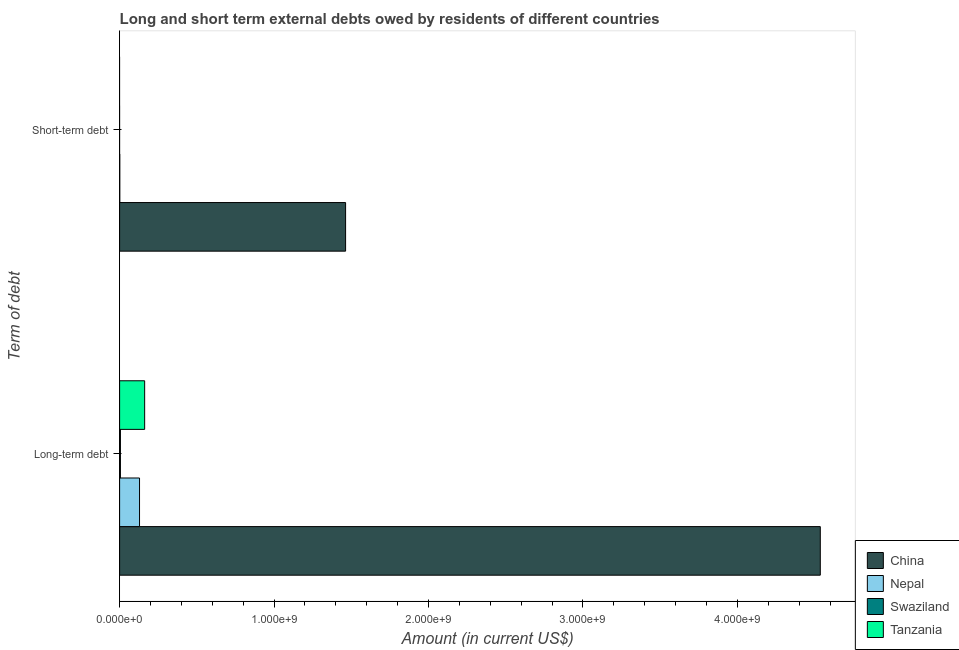How many bars are there on the 2nd tick from the top?
Your answer should be compact. 4. What is the label of the 2nd group of bars from the top?
Offer a very short reply. Long-term debt. Across all countries, what is the maximum long-term debts owed by residents?
Give a very brief answer. 4.54e+09. Across all countries, what is the minimum short-term debts owed by residents?
Provide a succinct answer. 0. What is the total short-term debts owed by residents in the graph?
Make the answer very short. 1.46e+09. What is the difference between the long-term debts owed by residents in Nepal and that in China?
Your response must be concise. -4.41e+09. What is the difference between the short-term debts owed by residents in Swaziland and the long-term debts owed by residents in Tanzania?
Your response must be concise. -1.62e+08. What is the average long-term debts owed by residents per country?
Provide a short and direct response. 1.21e+09. What is the difference between the short-term debts owed by residents and long-term debts owed by residents in Nepal?
Provide a succinct answer. -1.28e+08. What is the ratio of the long-term debts owed by residents in Swaziland to that in Tanzania?
Your answer should be compact. 0.03. Is the long-term debts owed by residents in Nepal less than that in Swaziland?
Ensure brevity in your answer.  No. How many countries are there in the graph?
Your answer should be compact. 4. Are the values on the major ticks of X-axis written in scientific E-notation?
Give a very brief answer. Yes. Where does the legend appear in the graph?
Keep it short and to the point. Bottom right. How are the legend labels stacked?
Make the answer very short. Vertical. What is the title of the graph?
Provide a short and direct response. Long and short term external debts owed by residents of different countries. What is the label or title of the X-axis?
Your response must be concise. Amount (in current US$). What is the label or title of the Y-axis?
Keep it short and to the point. Term of debt. What is the Amount (in current US$) of China in Long-term debt?
Offer a very short reply. 4.54e+09. What is the Amount (in current US$) of Nepal in Long-term debt?
Your answer should be very brief. 1.29e+08. What is the Amount (in current US$) in Swaziland in Long-term debt?
Give a very brief answer. 5.23e+06. What is the Amount (in current US$) in Tanzania in Long-term debt?
Offer a very short reply. 1.62e+08. What is the Amount (in current US$) in China in Short-term debt?
Keep it short and to the point. 1.46e+09. What is the Amount (in current US$) in Nepal in Short-term debt?
Offer a terse response. 1.10e+06. What is the Amount (in current US$) of Tanzania in Short-term debt?
Ensure brevity in your answer.  0. Across all Term of debt, what is the maximum Amount (in current US$) of China?
Ensure brevity in your answer.  4.54e+09. Across all Term of debt, what is the maximum Amount (in current US$) of Nepal?
Make the answer very short. 1.29e+08. Across all Term of debt, what is the maximum Amount (in current US$) in Swaziland?
Make the answer very short. 5.23e+06. Across all Term of debt, what is the maximum Amount (in current US$) in Tanzania?
Give a very brief answer. 1.62e+08. Across all Term of debt, what is the minimum Amount (in current US$) of China?
Ensure brevity in your answer.  1.46e+09. Across all Term of debt, what is the minimum Amount (in current US$) in Nepal?
Provide a succinct answer. 1.10e+06. Across all Term of debt, what is the minimum Amount (in current US$) of Tanzania?
Offer a very short reply. 0. What is the total Amount (in current US$) in China in the graph?
Provide a short and direct response. 6.00e+09. What is the total Amount (in current US$) in Nepal in the graph?
Keep it short and to the point. 1.30e+08. What is the total Amount (in current US$) in Swaziland in the graph?
Ensure brevity in your answer.  5.23e+06. What is the total Amount (in current US$) in Tanzania in the graph?
Offer a very short reply. 1.62e+08. What is the difference between the Amount (in current US$) in China in Long-term debt and that in Short-term debt?
Offer a terse response. 3.07e+09. What is the difference between the Amount (in current US$) of Nepal in Long-term debt and that in Short-term debt?
Keep it short and to the point. 1.28e+08. What is the difference between the Amount (in current US$) in China in Long-term debt and the Amount (in current US$) in Nepal in Short-term debt?
Offer a terse response. 4.54e+09. What is the average Amount (in current US$) of China per Term of debt?
Offer a very short reply. 3.00e+09. What is the average Amount (in current US$) of Nepal per Term of debt?
Provide a short and direct response. 6.50e+07. What is the average Amount (in current US$) of Swaziland per Term of debt?
Provide a short and direct response. 2.62e+06. What is the average Amount (in current US$) of Tanzania per Term of debt?
Your answer should be very brief. 8.11e+07. What is the difference between the Amount (in current US$) in China and Amount (in current US$) in Nepal in Long-term debt?
Give a very brief answer. 4.41e+09. What is the difference between the Amount (in current US$) in China and Amount (in current US$) in Swaziland in Long-term debt?
Your answer should be very brief. 4.53e+09. What is the difference between the Amount (in current US$) of China and Amount (in current US$) of Tanzania in Long-term debt?
Your answer should be very brief. 4.37e+09. What is the difference between the Amount (in current US$) of Nepal and Amount (in current US$) of Swaziland in Long-term debt?
Provide a short and direct response. 1.24e+08. What is the difference between the Amount (in current US$) in Nepal and Amount (in current US$) in Tanzania in Long-term debt?
Ensure brevity in your answer.  -3.32e+07. What is the difference between the Amount (in current US$) in Swaziland and Amount (in current US$) in Tanzania in Long-term debt?
Keep it short and to the point. -1.57e+08. What is the difference between the Amount (in current US$) in China and Amount (in current US$) in Nepal in Short-term debt?
Ensure brevity in your answer.  1.46e+09. What is the ratio of the Amount (in current US$) in China in Long-term debt to that in Short-term debt?
Offer a very short reply. 3.1. What is the ratio of the Amount (in current US$) of Nepal in Long-term debt to that in Short-term debt?
Provide a succinct answer. 117.2. What is the difference between the highest and the second highest Amount (in current US$) in China?
Provide a short and direct response. 3.07e+09. What is the difference between the highest and the second highest Amount (in current US$) in Nepal?
Provide a short and direct response. 1.28e+08. What is the difference between the highest and the lowest Amount (in current US$) in China?
Offer a very short reply. 3.07e+09. What is the difference between the highest and the lowest Amount (in current US$) in Nepal?
Ensure brevity in your answer.  1.28e+08. What is the difference between the highest and the lowest Amount (in current US$) in Swaziland?
Your answer should be very brief. 5.23e+06. What is the difference between the highest and the lowest Amount (in current US$) of Tanzania?
Provide a succinct answer. 1.62e+08. 